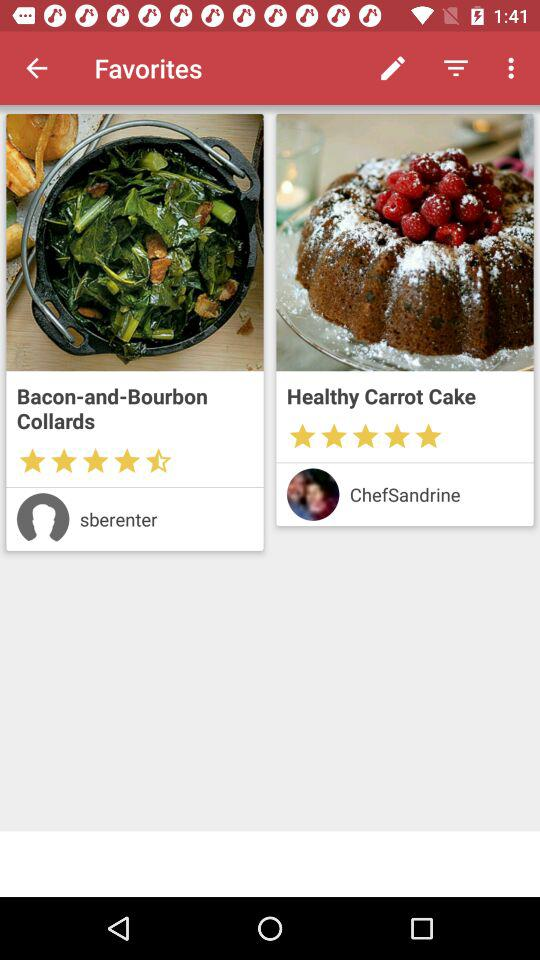What is the name of the chef? The name of the chef is ChefSandrine. 